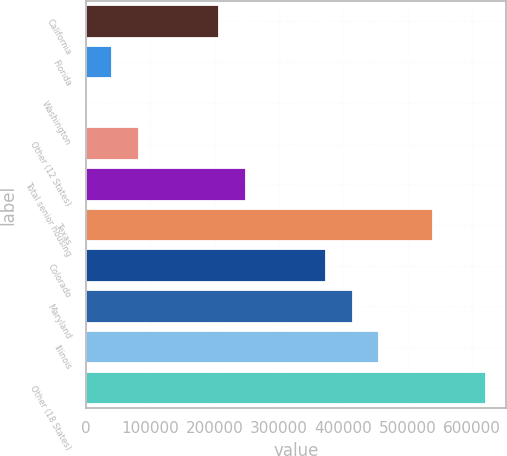Convert chart. <chart><loc_0><loc_0><loc_500><loc_500><bar_chart><fcel>California<fcel>Florida<fcel>Washington<fcel>Other (12 States)<fcel>Total senior housing<fcel>Texas<fcel>Colorado<fcel>Maryland<fcel>Illinois<fcel>Other (18 States)<nl><fcel>207156<fcel>41432.1<fcel>1<fcel>82863.2<fcel>248588<fcel>538605<fcel>372881<fcel>414312<fcel>455743<fcel>621468<nl></chart> 